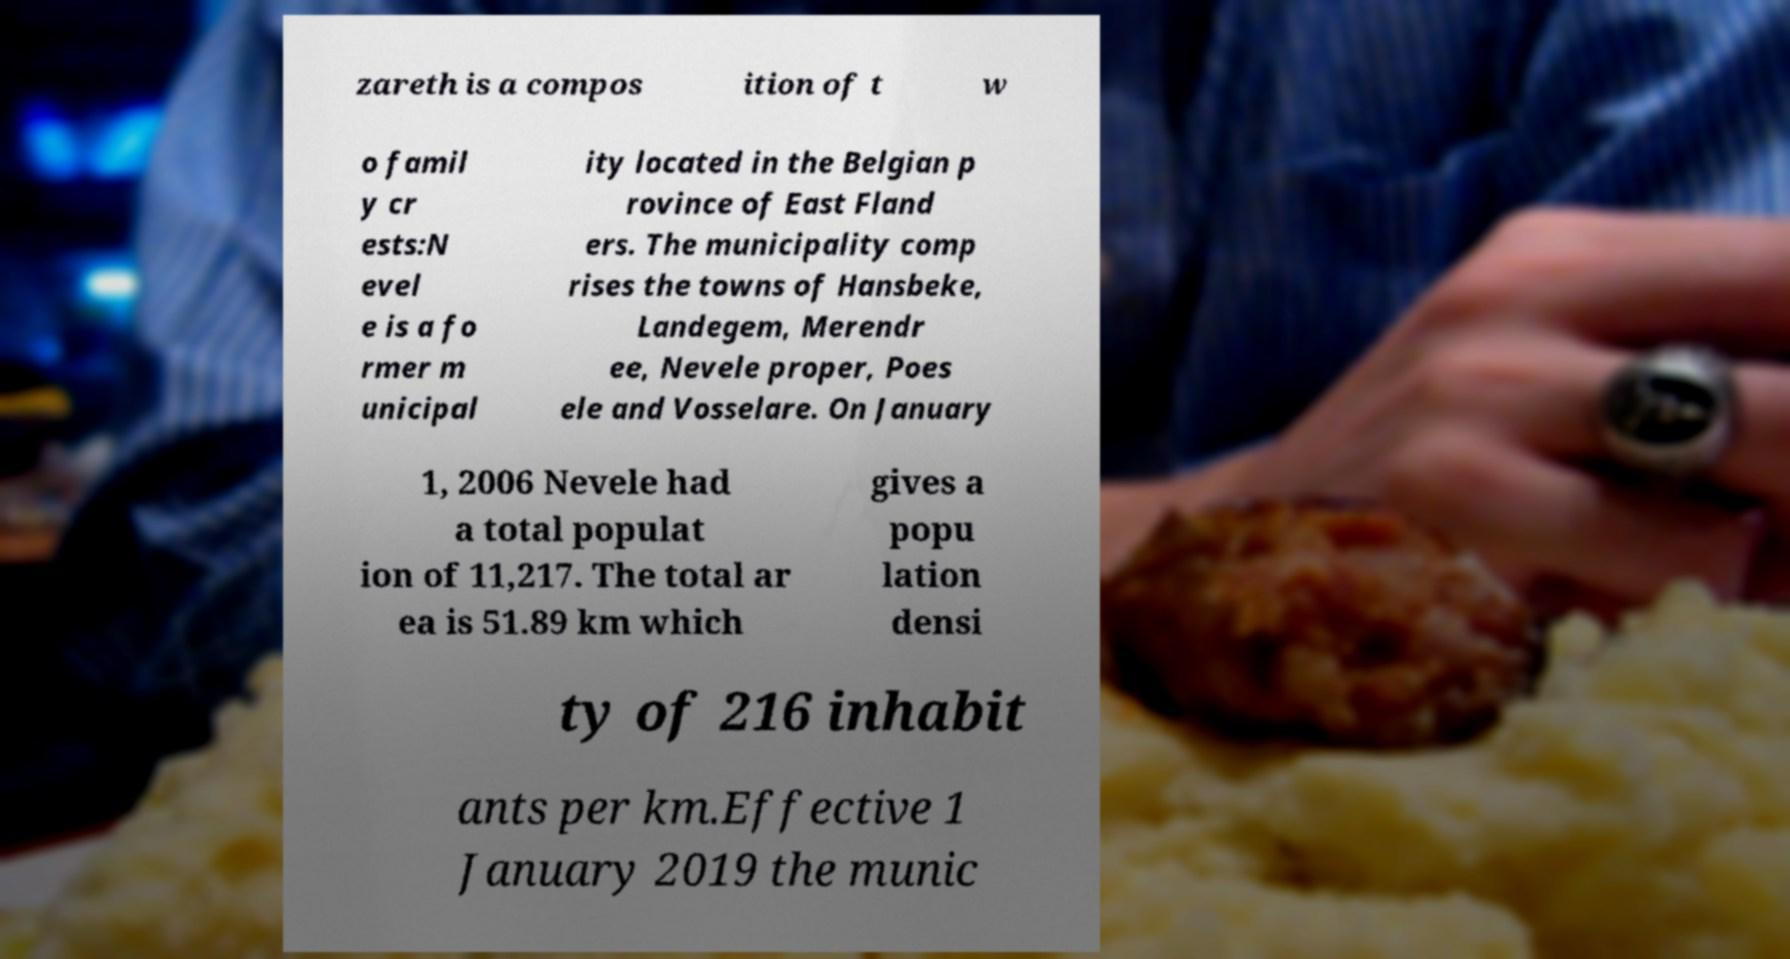Can you read and provide the text displayed in the image?This photo seems to have some interesting text. Can you extract and type it out for me? zareth is a compos ition of t w o famil y cr ests:N evel e is a fo rmer m unicipal ity located in the Belgian p rovince of East Fland ers. The municipality comp rises the towns of Hansbeke, Landegem, Merendr ee, Nevele proper, Poes ele and Vosselare. On January 1, 2006 Nevele had a total populat ion of 11,217. The total ar ea is 51.89 km which gives a popu lation densi ty of 216 inhabit ants per km.Effective 1 January 2019 the munic 